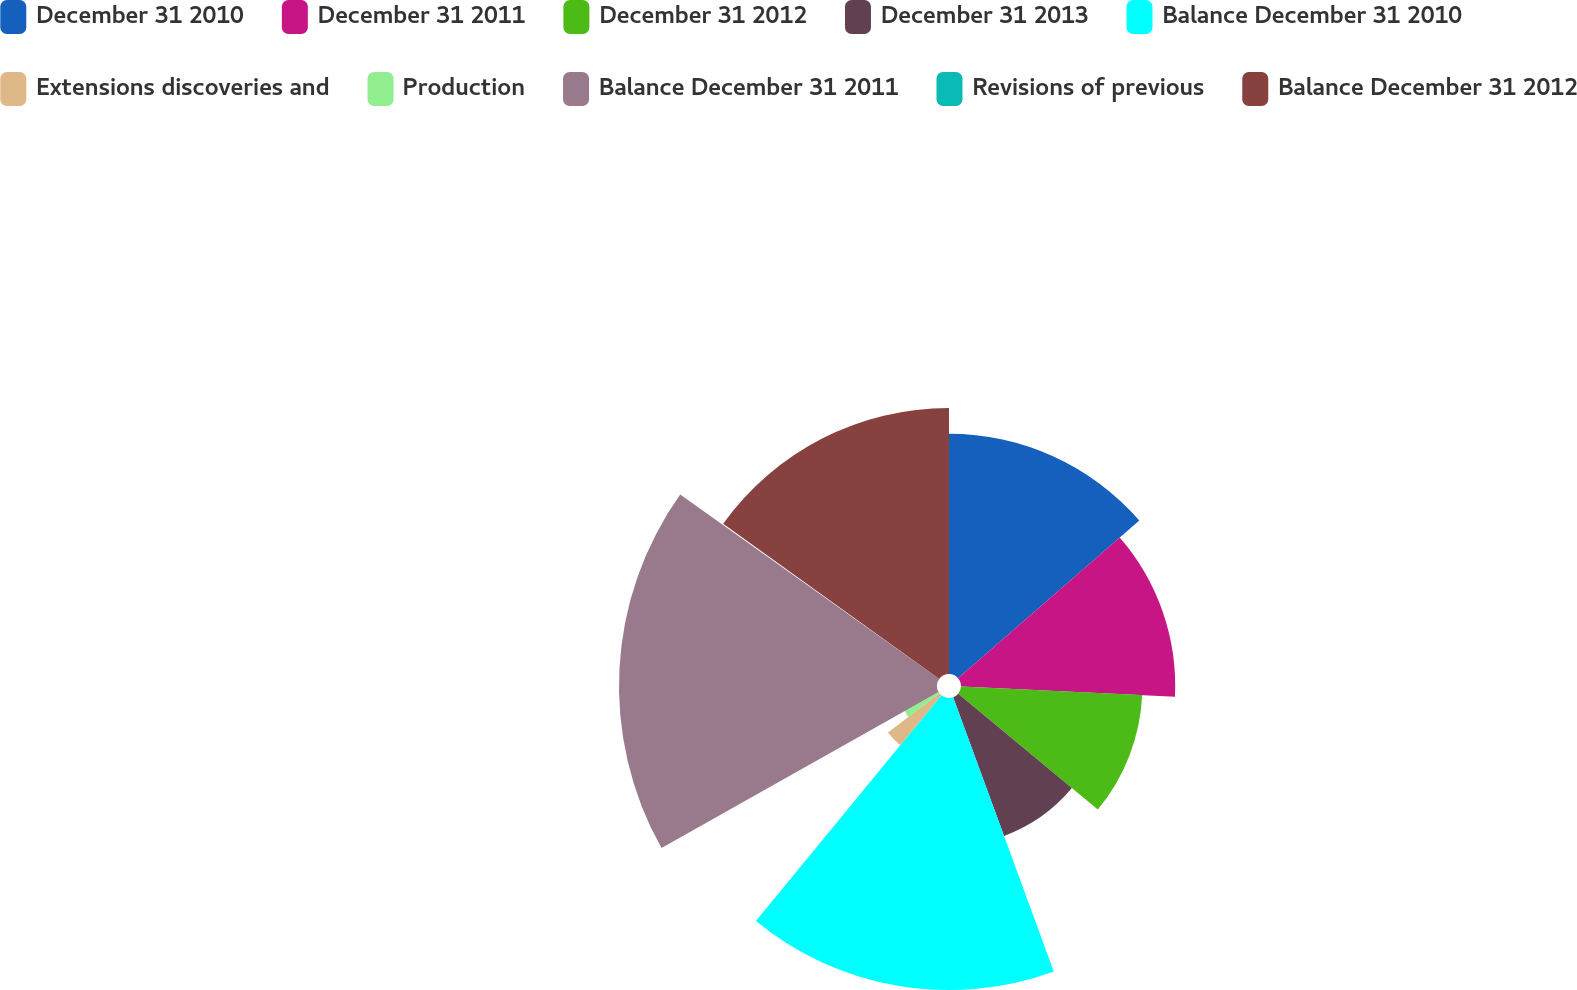<chart> <loc_0><loc_0><loc_500><loc_500><pie_chart><fcel>December 31 2010<fcel>December 31 2011<fcel>December 31 2012<fcel>December 31 2013<fcel>Balance December 31 2010<fcel>Extensions discoveries and<fcel>Production<fcel>Balance December 31 2011<fcel>Revisions of previous<fcel>Balance December 31 2012<nl><fcel>13.61%<fcel>12.14%<fcel>10.28%<fcel>8.37%<fcel>16.55%<fcel>3.67%<fcel>2.21%<fcel>18.02%<fcel>0.07%<fcel>15.08%<nl></chart> 